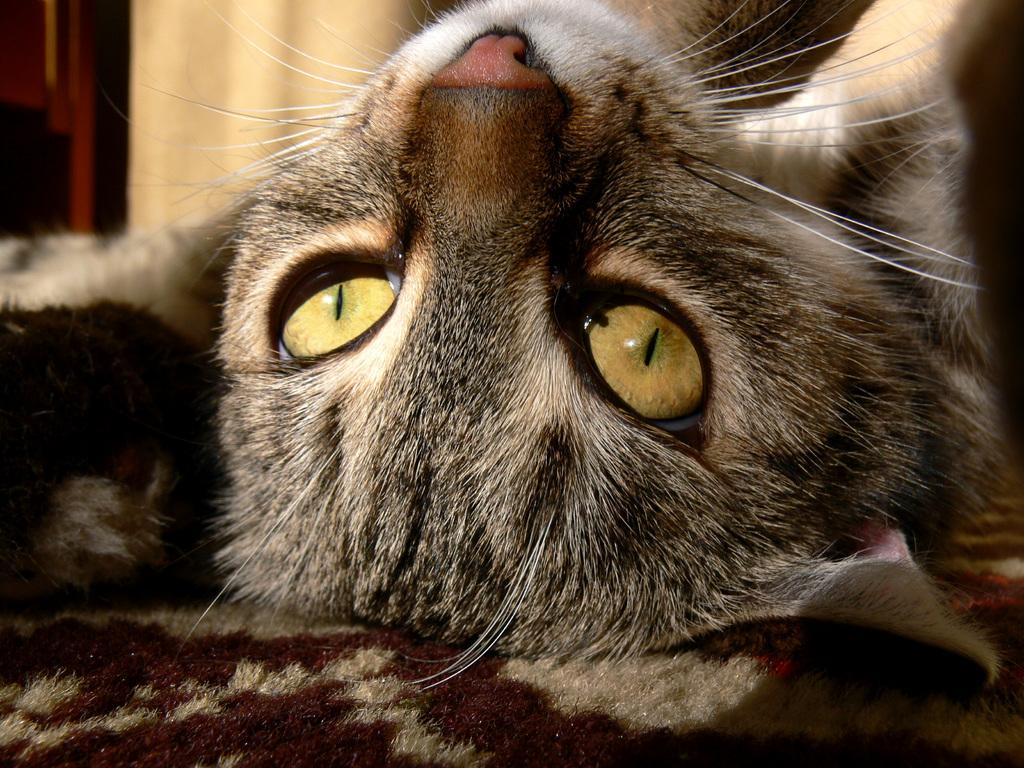Where was the image taken? The image was taken indoors. What can be seen in the background of the image? There is a wall in the background of the image. What is the main subject of the image? The main subject of the image is a cat lying on a towel in the middle of the image. What type of reaction does the cat have to the trip in the image? There is no trip present in the image, and therefore no reaction from the cat can be observed. 